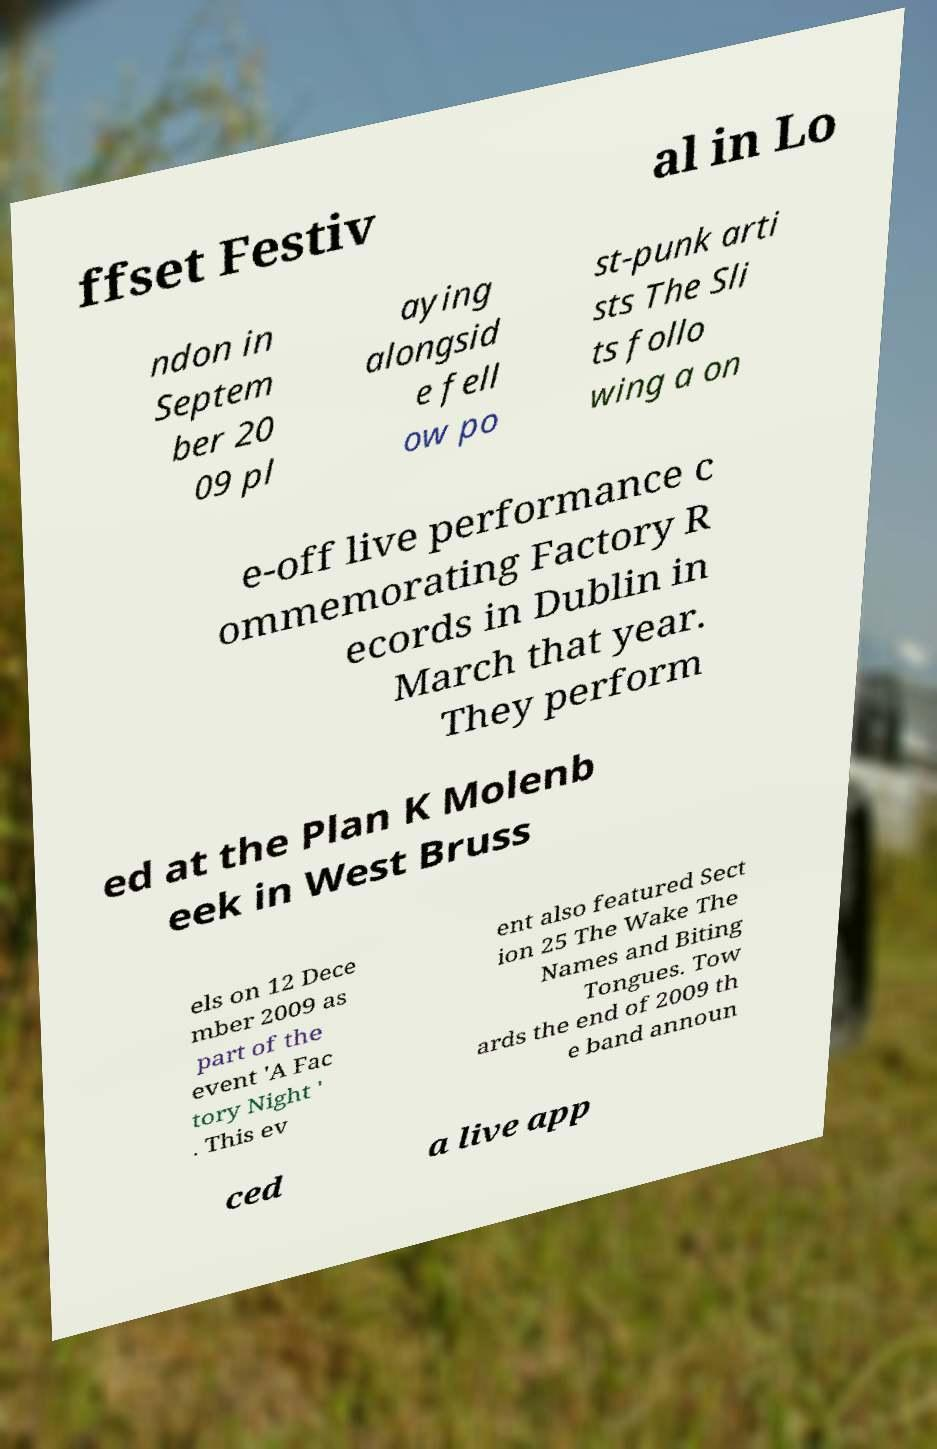Can you accurately transcribe the text from the provided image for me? ffset Festiv al in Lo ndon in Septem ber 20 09 pl aying alongsid e fell ow po st-punk arti sts The Sli ts follo wing a on e-off live performance c ommemorating Factory R ecords in Dublin in March that year. They perform ed at the Plan K Molenb eek in West Bruss els on 12 Dece mber 2009 as part of the event 'A Fac tory Night ' . This ev ent also featured Sect ion 25 The Wake The Names and Biting Tongues. Tow ards the end of 2009 th e band announ ced a live app 